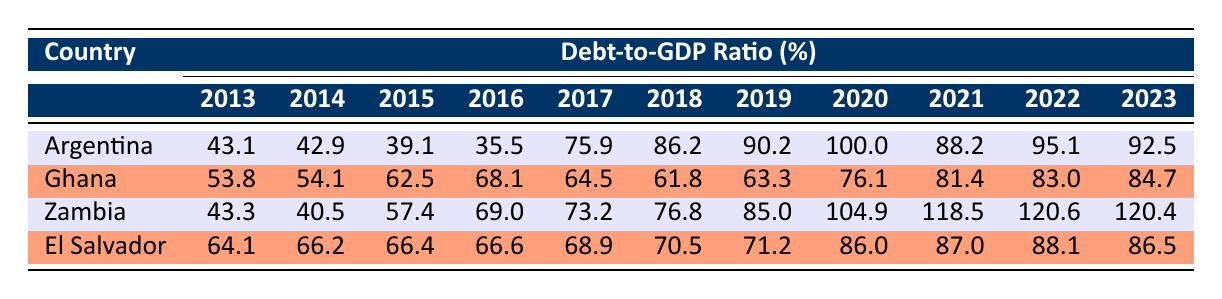What was the Debt-to-GDP ratio of Argentina in 2016? By looking at the row for Argentina, the debt-to-GDP ratio for the year 2016 is directly stated as 35.5%.
Answer: 35.5 What is the Debt-to-GDP ratio of Ghana in 2021? The row for Ghana indicates that the debt-to-GDP ratio in 2021 is 81.4%.
Answer: 81.4 Which country had the highest Debt-to-GDP ratio in 2020? Looking at the 2020 column for all countries, Zambia has the highest ratio at 104.9%, compared to Argentina's 100.0%, Ghana's 76.1%, and El Salvador's 86.0%.
Answer: Zambia What was the average Debt-to-GDP ratio for El Salvador from 2013 to 2023? To find the average for El Salvador, we sum up the values from each year: (64.1 + 66.2 + 66.4 + 66.6 + 68.9 + 70.5 + 71.2 + 86.0 + 87.0 + 88.1 + 86.5) =  885.5. There are 11 data points, so the average is 885.5 / 11 = 80.5.
Answer: 80.5 Did Ghana's Debt-to-GDP ratio decrease from 2016 to 2017? In 2016, Ghana's ratio was 68.1%, which decreased to 64.5% in 2017, indicating a decline.
Answer: Yes Which country experienced the most significant increase in Debt-to-GDP ratio from 2019 to 2020? Zambia increased from 85.0% in 2019 to 104.9% in 2020, resulting in an increase of 19.9%. Argentina's increase was from 90.2% to 100.0%, which is 9.8%. This shows that Zambia had the largest increase.
Answer: Zambia What was the Debt-to-GDP ratio for Zambia in 2023 and how does this compare to its ratio in 2015? In 2023, Zambia's ratio is 120.4%, while in 2015 it was 57.4%. This shows a significant increase of 63.0%.
Answer: 120.4% (increase from 57.4%) Is it true that all the countries listed had a Debt-to-GDP ratio above 70% in 2020? Checking the 2020 column, Argentina is at 100.0%, Ghana is at 76.1%, Zambia is at 104.9%, and El Salvador is at 86.0%. Thus, all countries had ratios above 70%.
Answer: Yes Which country had a Debt-to-GDP ratio closest to 90% in 2022? In 2022, Argentina was at 95.1%, Ghana was at 83.0%, Zambia was at 120.6%, and El Salvador was at 88.1%. Out of these, El Salvador at 88.1% is closest to 90%.
Answer: El Salvador 